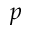<formula> <loc_0><loc_0><loc_500><loc_500>p</formula> 